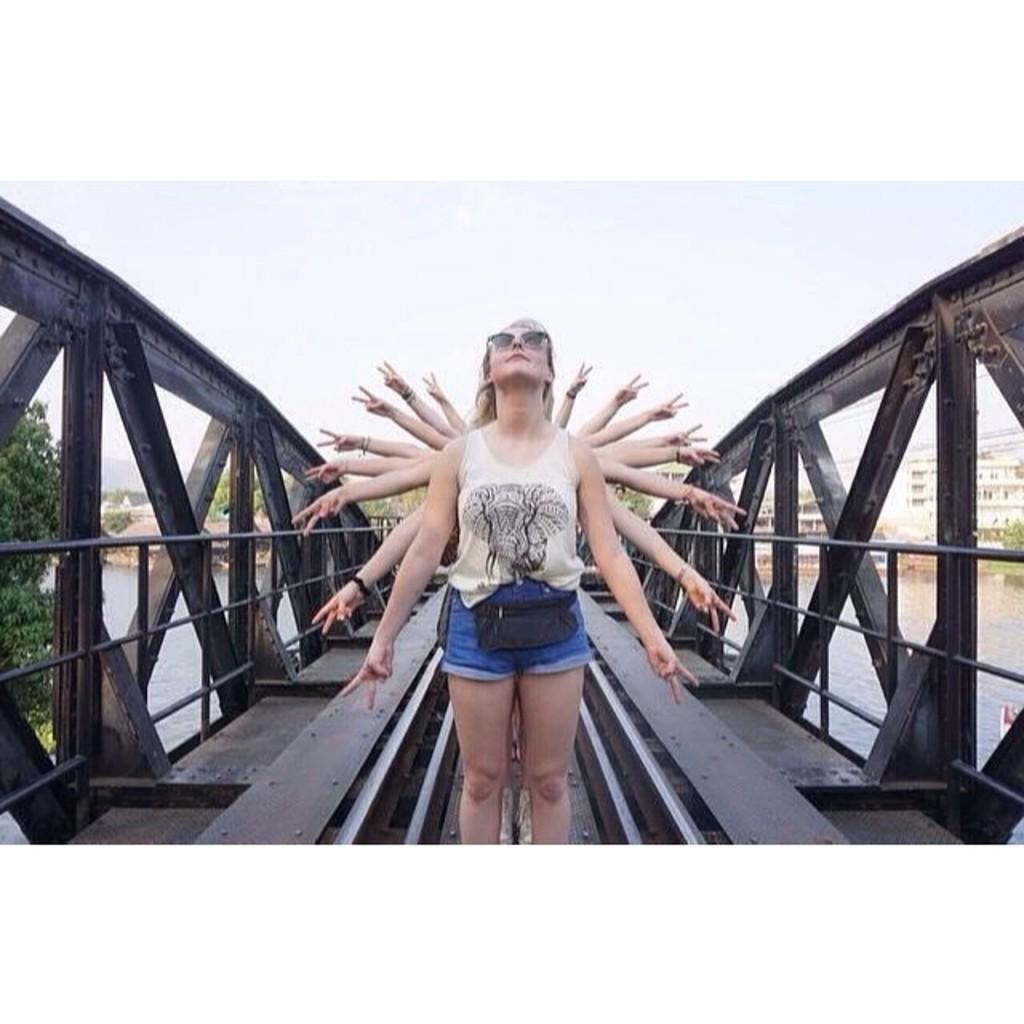How would you summarize this image in a sentence or two? This picture shows few people standing one at the back in the line and we see their hands and we see a bridge and trees, Buildings and we see water and a cloudy Sky. We see a woman wore sunglasses and a handbag. 